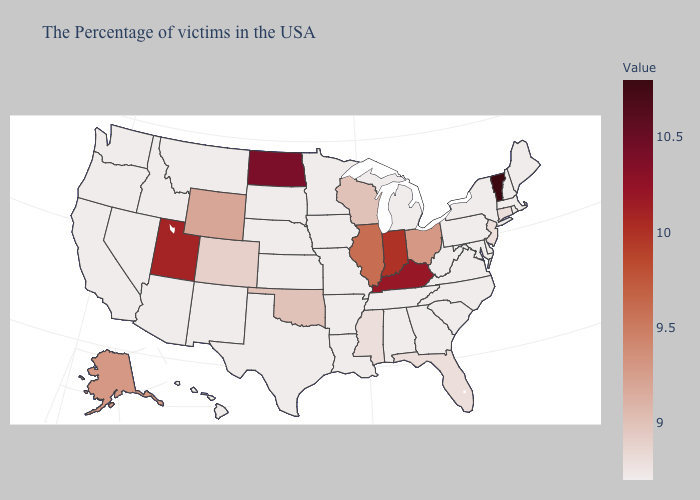Does Florida have a lower value than Indiana?
Concise answer only. Yes. Does the map have missing data?
Short answer required. No. Is the legend a continuous bar?
Be succinct. Yes. Among the states that border California , which have the highest value?
Keep it brief. Arizona, Nevada, Oregon. Does Ohio have a lower value than Michigan?
Quick response, please. No. Does the map have missing data?
Give a very brief answer. No. Does the map have missing data?
Concise answer only. No. Which states have the lowest value in the USA?
Quick response, please. Maine, Massachusetts, Rhode Island, New Hampshire, New York, Delaware, Maryland, Pennsylvania, Virginia, North Carolina, South Carolina, West Virginia, Georgia, Michigan, Alabama, Tennessee, Louisiana, Missouri, Arkansas, Minnesota, Iowa, Kansas, Nebraska, Texas, South Dakota, New Mexico, Montana, Arizona, Idaho, Nevada, California, Washington, Oregon, Hawaii. Which states hav the highest value in the South?
Answer briefly. Kentucky. 